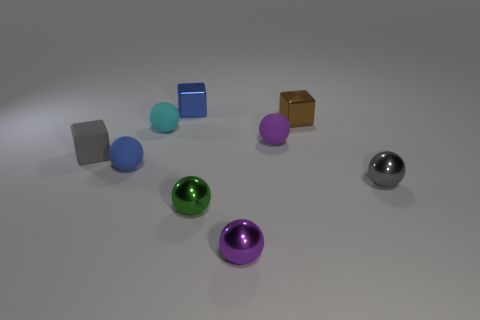Subtract all cyan balls. How many balls are left? 5 Subtract all purple balls. How many balls are left? 4 Subtract all green balls. Subtract all green cylinders. How many balls are left? 5 Add 1 green metallic spheres. How many objects exist? 10 Subtract all blocks. How many objects are left? 6 Subtract all blue metal things. Subtract all small blue metallic objects. How many objects are left? 7 Add 9 small matte blocks. How many small matte blocks are left? 10 Add 2 blue metallic things. How many blue metallic things exist? 3 Subtract 2 purple spheres. How many objects are left? 7 